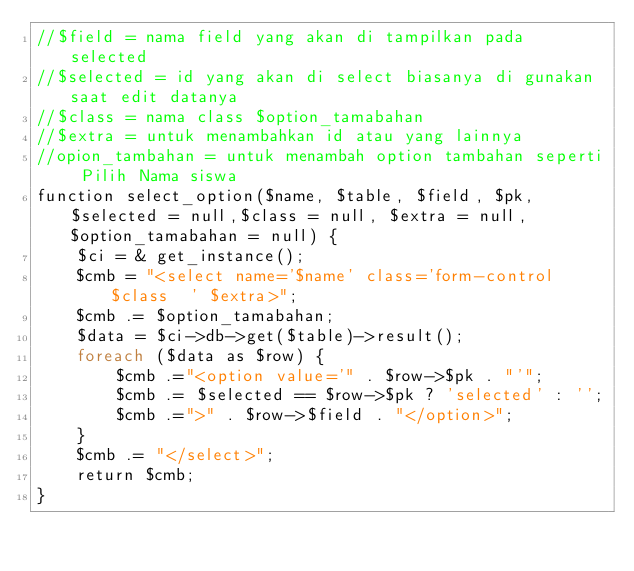<code> <loc_0><loc_0><loc_500><loc_500><_PHP_>//$field = nama field yang akan di tampilkan pada selected
//$selected = id yang akan di select biasanya di gunakan saat edit datanya
//$class = nama class $option_tamabahan
//$extra = untuk menambahkan id atau yang lainnya
//opion_tambahan = untuk menambah option tambahan seperti Pilih Nama siswa
function select_option($name, $table, $field, $pk, $selected = null,$class = null, $extra = null, $option_tamabahan = null) {
    $ci = & get_instance();
    $cmb = "<select name='$name' class='form-control $class  ' $extra>";
    $cmb .= $option_tamabahan;
    $data = $ci->db->get($table)->result();
    foreach ($data as $row) {
        $cmb .="<option value='" . $row->$pk . "'";
        $cmb .= $selected == $row->$pk ? 'selected' : '';
        $cmb .=">" . $row->$field . "</option>";
    }
    $cmb .= "</select>";
    return $cmb;
}</code> 